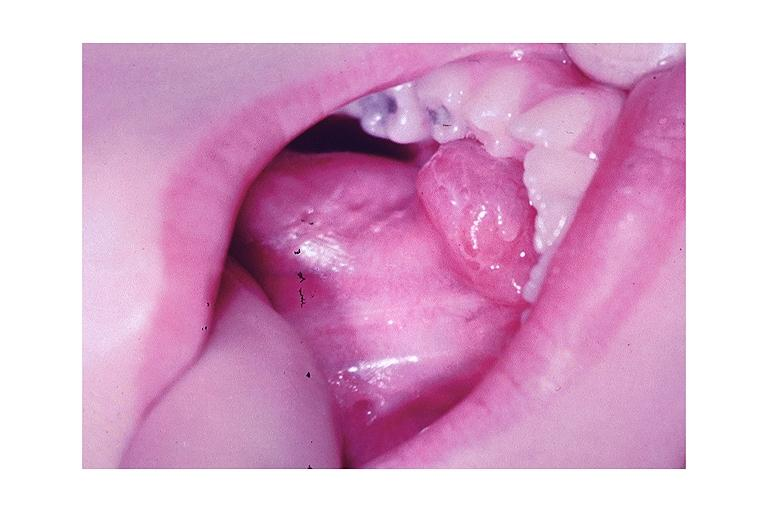does this image show ranula?
Answer the question using a single word or phrase. Yes 